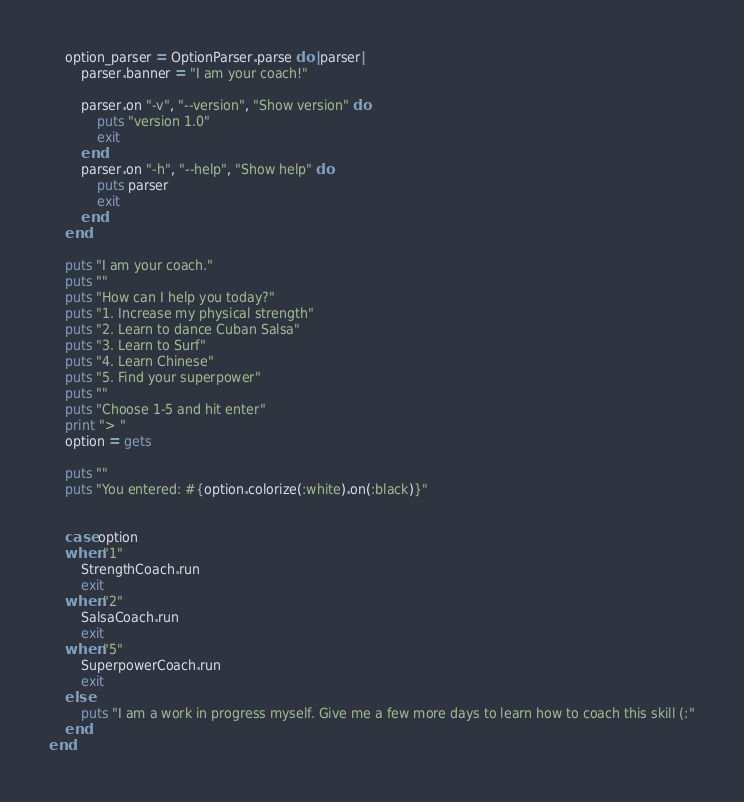<code> <loc_0><loc_0><loc_500><loc_500><_Crystal_>
	option_parser = OptionParser.parse do |parser|
		parser.banner = "I am your coach!"

		parser.on "-v", "--version", "Show version" do
			puts "version 1.0"
			exit
		end
		parser.on "-h", "--help", "Show help" do
			puts parser
			exit
		end
	end

	puts "I am your coach."
	puts ""
	puts "How can I help you today?"
	puts "1. Increase my physical strength"
	puts "2. Learn to dance Cuban Salsa"
	puts "3. Learn to Surf"
	puts "4. Learn Chinese"
	puts "5. Find your superpower"
	puts ""
	puts "Choose 1-5 and hit enter"
	print "> "
	option = gets

	puts ""
	puts "You entered: #{option.colorize(:white).on(:black)}"


	case option
	when "1"
		StrengthCoach.run
		exit
	when "2"
		SalsaCoach.run
		exit
	when "5"
		SuperpowerCoach.run
		exit
	else
		puts "I am a work in progress myself. Give me a few more days to learn how to coach this skill (:"
	end
end
</code> 